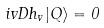<formula> <loc_0><loc_0><loc_500><loc_500>i v D h _ { v } | Q \rangle = 0</formula> 